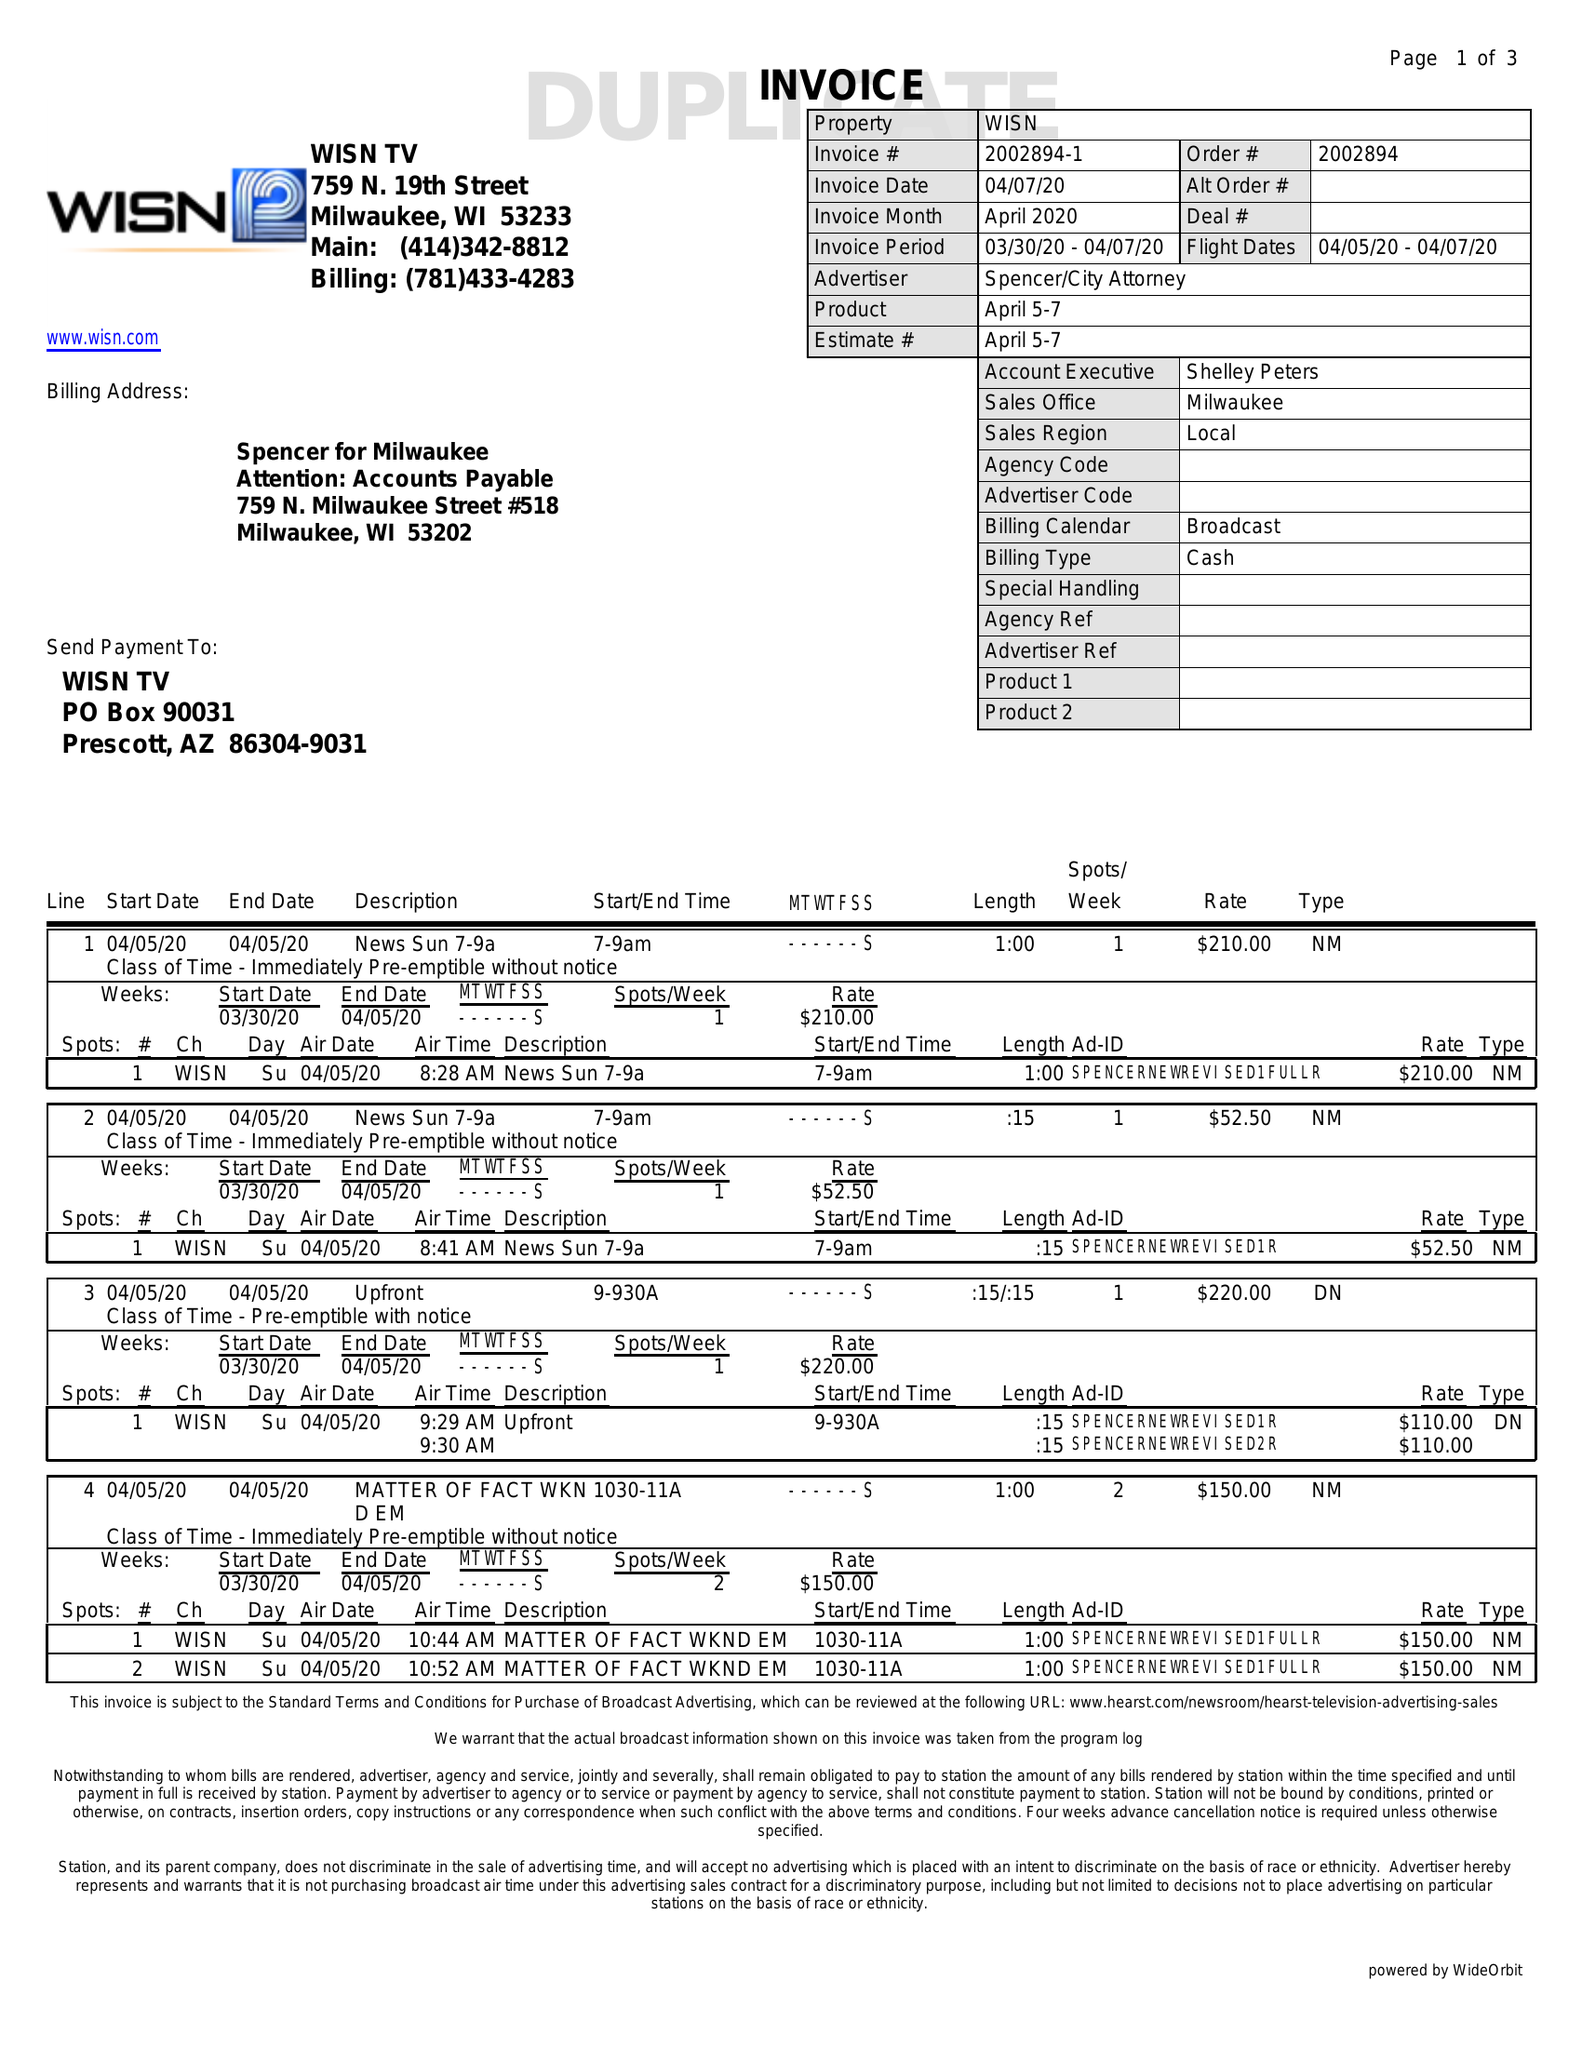What is the value for the contract_num?
Answer the question using a single word or phrase. 2002894 